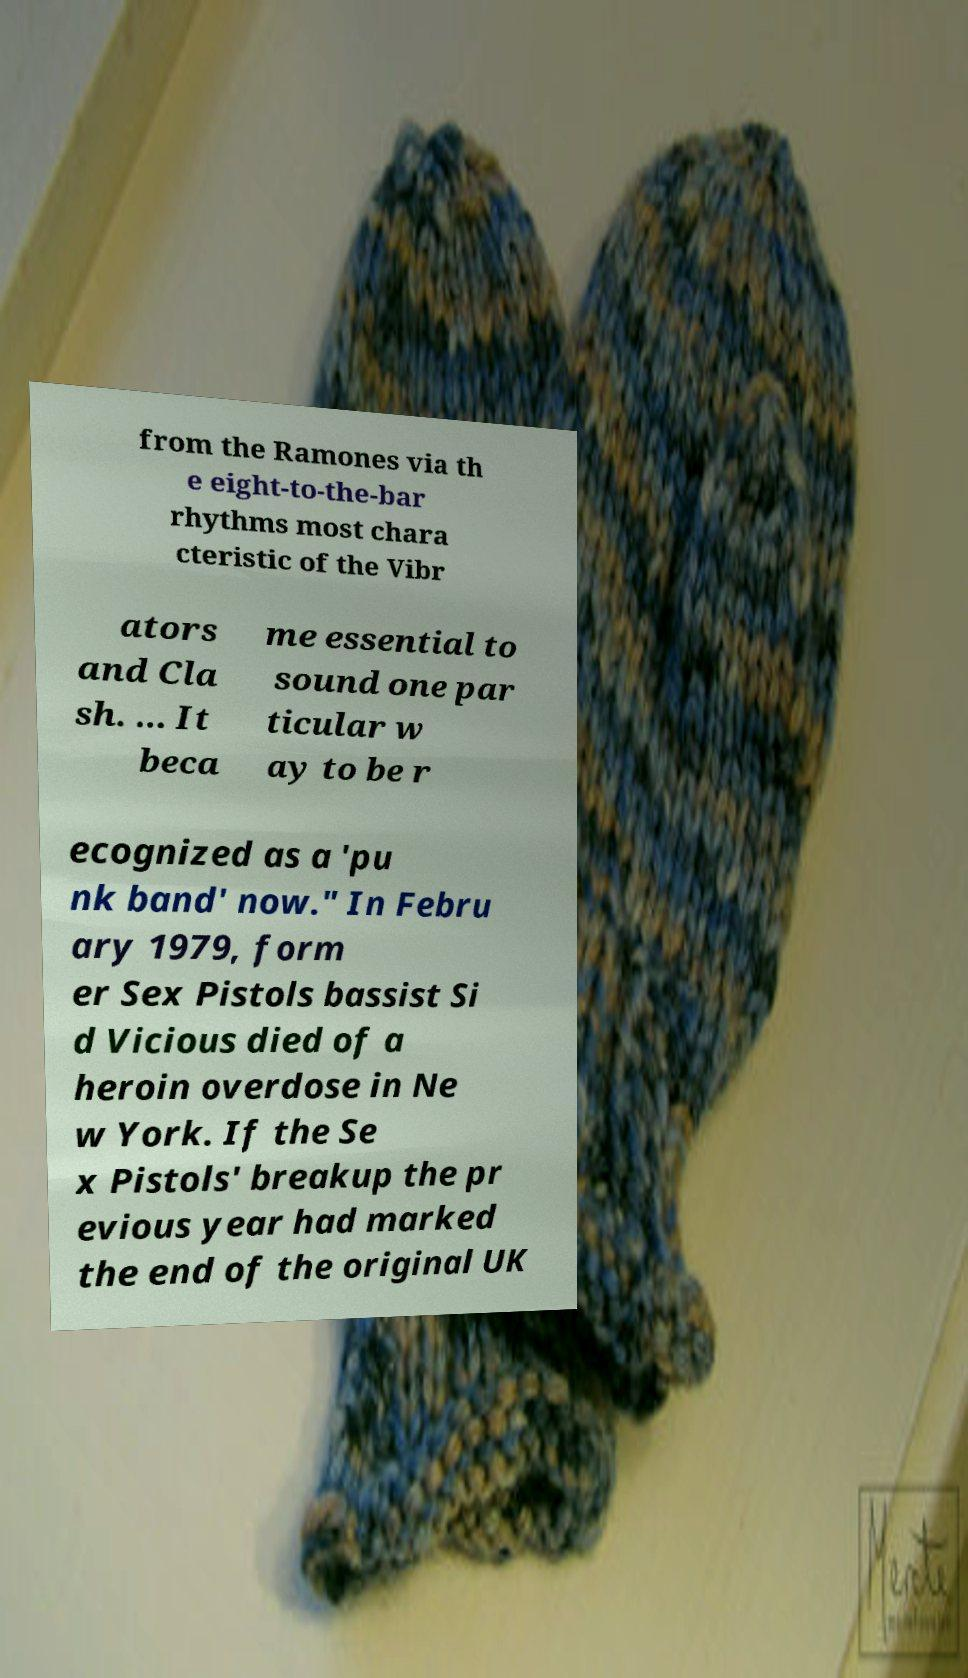What messages or text are displayed in this image? I need them in a readable, typed format. from the Ramones via th e eight-to-the-bar rhythms most chara cteristic of the Vibr ators and Cla sh. ... It beca me essential to sound one par ticular w ay to be r ecognized as a 'pu nk band' now." In Febru ary 1979, form er Sex Pistols bassist Si d Vicious died of a heroin overdose in Ne w York. If the Se x Pistols' breakup the pr evious year had marked the end of the original UK 